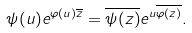<formula> <loc_0><loc_0><loc_500><loc_500>\psi ( u ) e ^ { \varphi ( u ) \overline { z } } = \overline { \psi ( z ) } e ^ { u \overline { \varphi ( z ) } } .</formula> 